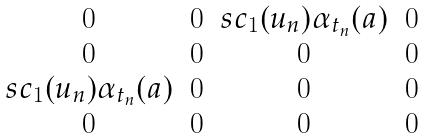Convert formula to latex. <formula><loc_0><loc_0><loc_500><loc_500>\begin{matrix} 0 & 0 & s c _ { 1 } ( u _ { n } ) \alpha _ { t _ { n } } ( a ) & 0 \\ 0 & 0 & 0 & 0 \\ s c _ { 1 } ( u _ { n } ) \alpha _ { t _ { n } } ( a ) & 0 & 0 & 0 \\ 0 & 0 & 0 & 0 \end{matrix}</formula> 